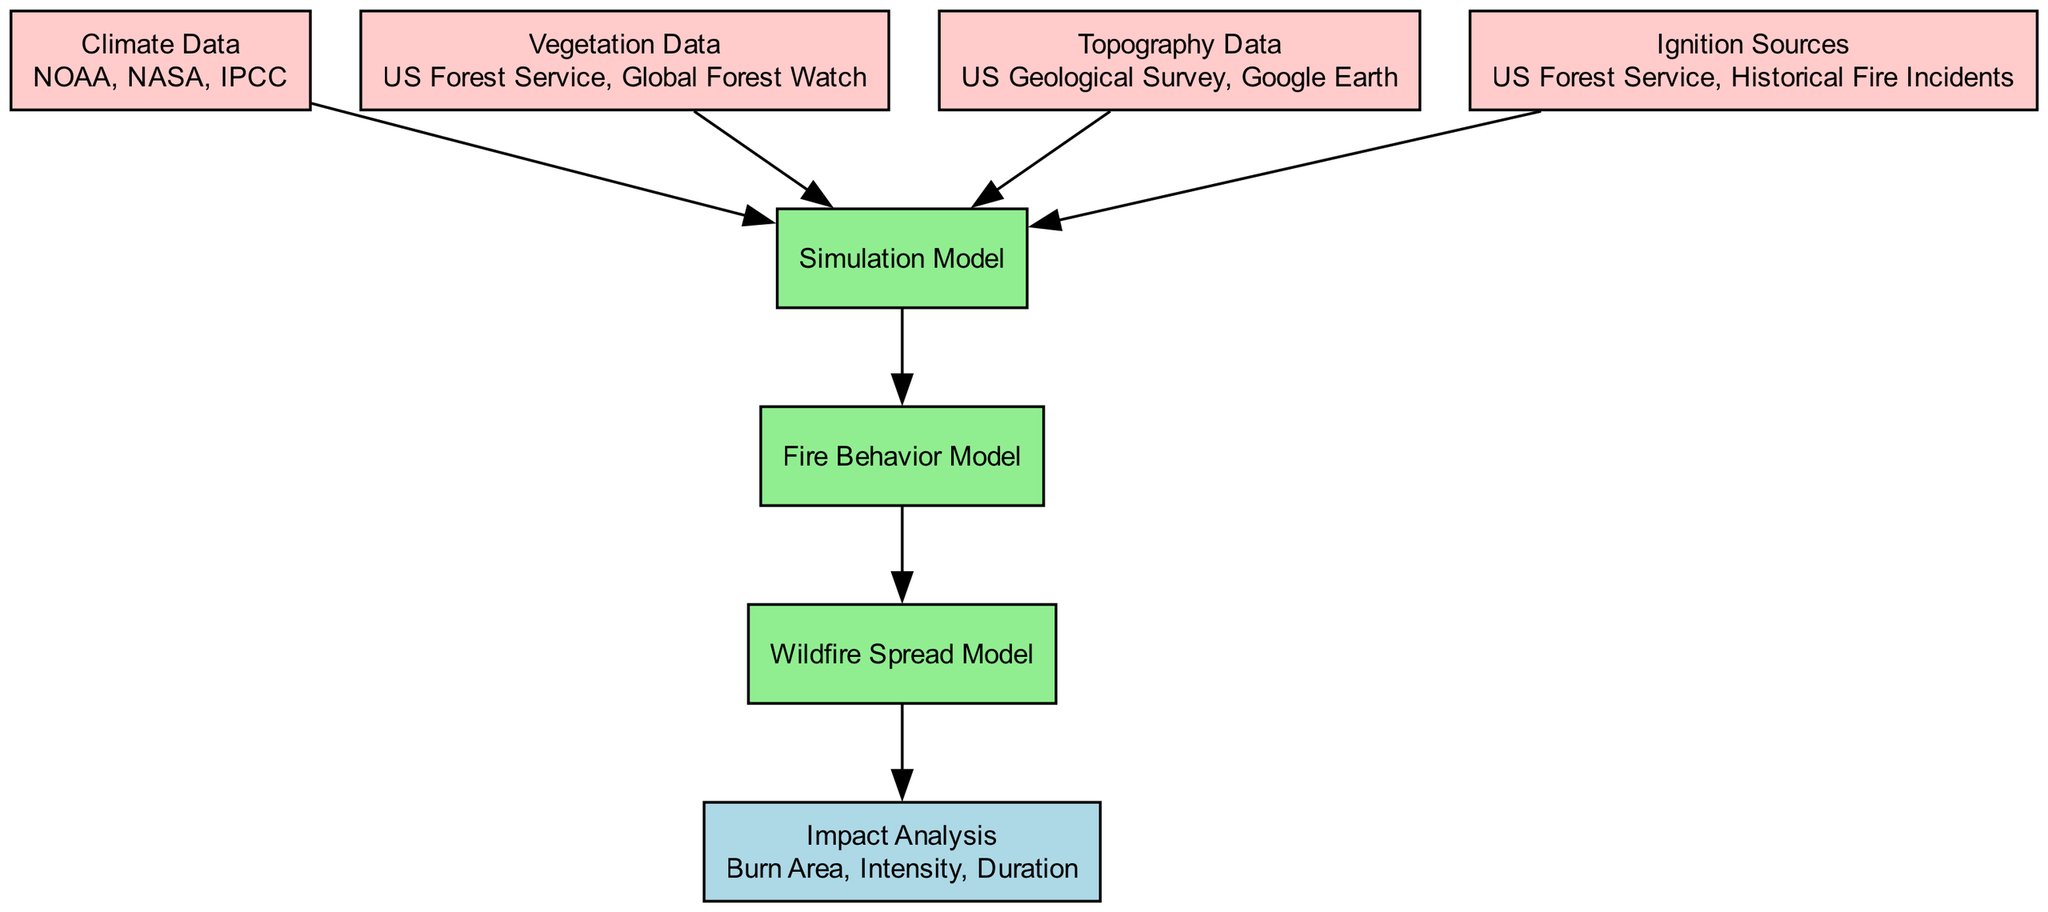What are the three input data types for the wildfire model? The diagram lists the following input data types: Climate Data, Vegetation Data, and Topography Data. Each of these inputs is essential for initializing the wildfire modeling process.
Answer: Climate Data, Vegetation Data, Topography Data Which model processes the ignition sources? Ignition Sources are directed to the Simulation Model in the diagram, implying that the Simulation Model utilizes these sources to conduct its analysis and simulations.
Answer: Simulation Model How many elements are connected to the Simulation Model? The Simulation Model receives connections from four different input nodes: Climate Data, Vegetation Data, Topography Data, and Ignition Sources. Therefore, the count of incoming connections is four.
Answer: Four What is the outcome of the Wildfire Spread Model? The Wildfire Spread Model contributes its results to the Impact Analysis output node, thus indicating that the outcome focuses on analyzing the spread's impact as measured by specific metrics.
Answer: Impact Analysis Which process comes directly after the Fire Behavior Model? The diagram shows that the Wildfire Spread Model is the next process after the Fire Behavior Model, meaning it directly follows the Fire Behavior Model in the sequence of processing.
Answer: Wildfire Spread Model Which types of data sources are indicated for Vegetation Data? The diagram specifies two sources for Vegetation Data: the US Forest Service and Global Forest Watch. They provide the necessary information related to vegetation types and their properties.
Answer: US Forest Service, Global Forest Watch What are the three metrics used in the Impact Analysis? The Impact Analysis in the diagram outlines three specific metrics for evaluation: Burn Area, Intensity, and Duration. These metrics assess the consequences of wildfires effectively.
Answer: Burn Area, Intensity, Duration What kind of methodology is used in the Simulation Model? According to the diagram, the Simulation Model employs methodologies like Cellular Automata and Agent-Based Models, which are essential approaches used in simulating the spread of wildfires.
Answer: Cellular Automata, Agent-Based Models In what order do the processes appear after the Simulation Model? Following the Simulation Model, the diagram shows the sequential flow: first to the Fire Behavior Model, then to the Wildfire Spread Model, reflecting the stepwise nature of analysis in wildfire modeling.
Answer: Fire Behavior Model, Wildfire Spread Model 